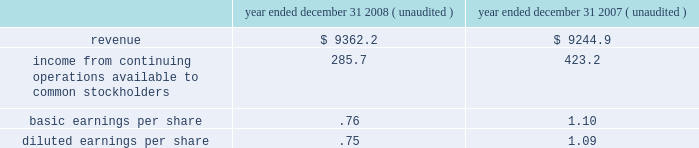Substantially all of the goodwill and other intangible assets recorded related to the acquisition of allied are not deductible for tax purposes .
Pro forma information the consolidated financial statements presented for republic include the operating results of allied from the date of the acquisition .
The following pro forma information is presented assuming the merger had been completed as of january 1 , 2007 .
The unaudited pro forma information presented below has been prepared for illustrative purposes and is not intended to be indicative of the results of operations that would have actually occurred had the acquisition been consummated at the beginning of the periods presented or of future results of the combined operations ( in millions , except share and per share amounts ) .
Year ended december 31 , year ended december 31 , ( unaudited ) ( unaudited ) .
The above unaudited pro forma financial information includes adjustments for amortization of identifiable intangible assets , accretion of discounts to fair value associated with debt , environmental , self-insurance and other liabilities , accretion of capping , closure and post-closure obligations and amortization of the related assets , and provision for income taxes .
Assets held for sale as a condition of the merger with allied in december 2008 , we reached a settlement with the doj requiring us to divest of certain operations serving fifteen metropolitan areas including los angeles , ca ; san francisco , ca ; denver , co ; atlanta , ga ; northwestern indiana ; lexington , ky ; flint , mi ; cape girardeau , mo ; charlotte , nc ; cleveland , oh ; philadelphia , pa ; greenville-spartanburg , sc ; and fort worth , houston and lubbock , tx .
The settlement requires us to divest 87 commercial waste collection routes , nine landfills and ten transfer stations , together with ancillary assets and , in three cases , access to landfill disposal capacity .
We have classified the assets and liabilities we expect to divest ( including accounts receivable , property and equipment , goodwill , and accrued landfill and environmental costs ) as assets held for sale in our consolidated balance sheet at december 31 , 2008 .
The assets held for sale related to operations that were republic 2019s prior to the merger with allied have been adjusted to the lower of their carrying amounts or estimated fair values less costs to sell , which resulted in us recognizing an asset impairment loss of $ 6.1 million in our consolidated statement of income for the year ended december 31 , 2008 .
The assets held for sale related to operations that were allied 2019s prior to the merger are recorded at their estimated fair values in our consolidated balance sheet as of december 31 , 2008 in accordance with the purchase method of accounting .
In february 2009 , we entered into an agreement to divest certain assets to waste connections , inc .
The assets covered by the agreement include six municipal solid waste landfills , six collection operations and three transfer stations across the following seven markets : los angeles , ca ; denver , co ; houston , tx ; lubbock , tx ; greenville-spartanburg , sc ; charlotte , nc ; and flint , mi .
The transaction with waste connections is subject to closing conditions regarding due diligence , regulatory approval and other customary matters .
Closing is expected to occur in the second quarter of 2009 .
Republic services , inc .
And subsidiaries notes to consolidated financial statements %%transmsg*** transmitting job : p14076 pcn : 106000000 ***%%pcmsg|104 |00046|yes|no|02/28/2009 21:07|0|0|page is valid , no graphics -- color : d| .
As of year ended december 31 2008 what was the number of shares available for the basic earnings per share? 
Rationale: since the earnings per share is equal to the the income from operations divide by the number of shares
Computations: (285.7 / .76)
Answer: 375.92105. 